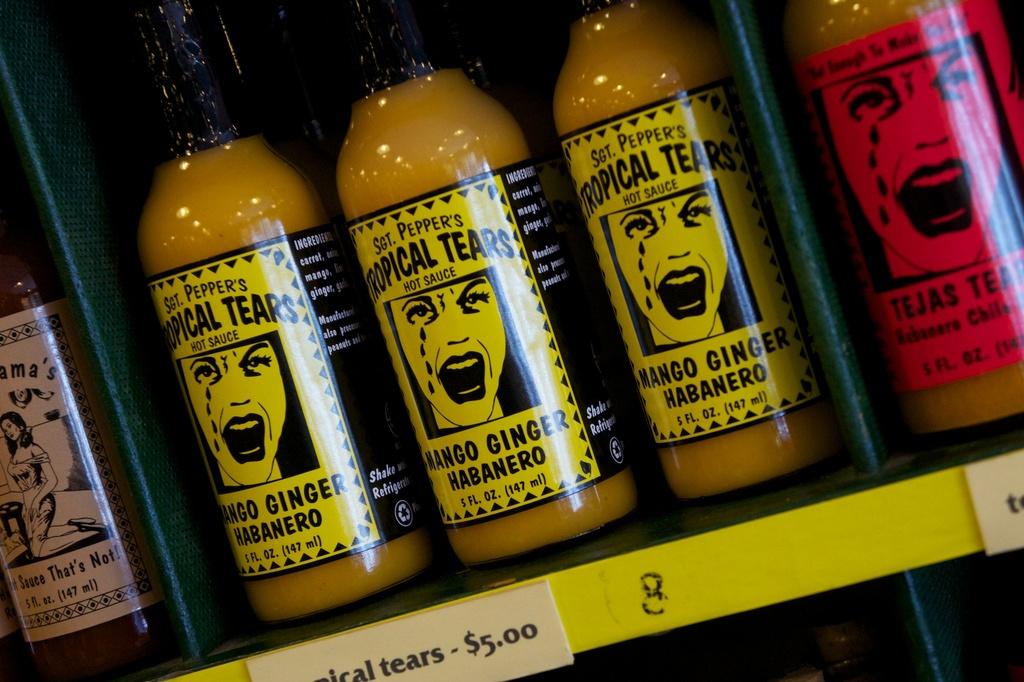What is pepper's military rank?
Make the answer very short. Sgt. 